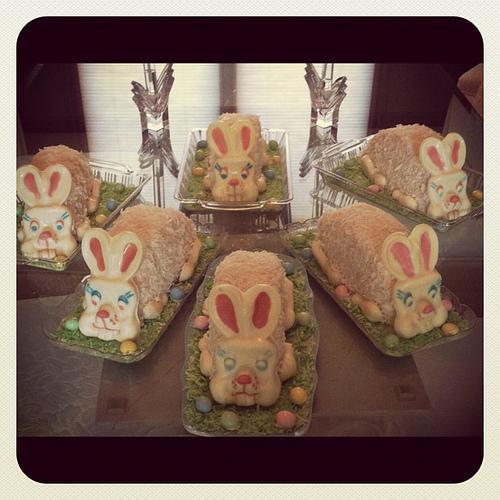How many bunnies are there?
Give a very brief answer. 6. 